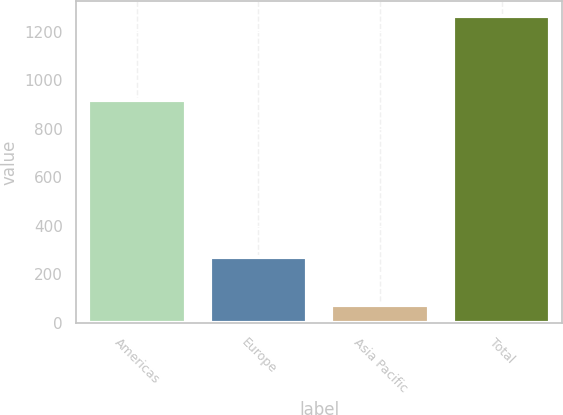Convert chart to OTSL. <chart><loc_0><loc_0><loc_500><loc_500><bar_chart><fcel>Americas<fcel>Europe<fcel>Asia Pacific<fcel>Total<nl><fcel>918.3<fcel>272.5<fcel>73.3<fcel>1264.1<nl></chart> 